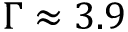Convert formula to latex. <formula><loc_0><loc_0><loc_500><loc_500>\Gamma \approx 3 . 9</formula> 